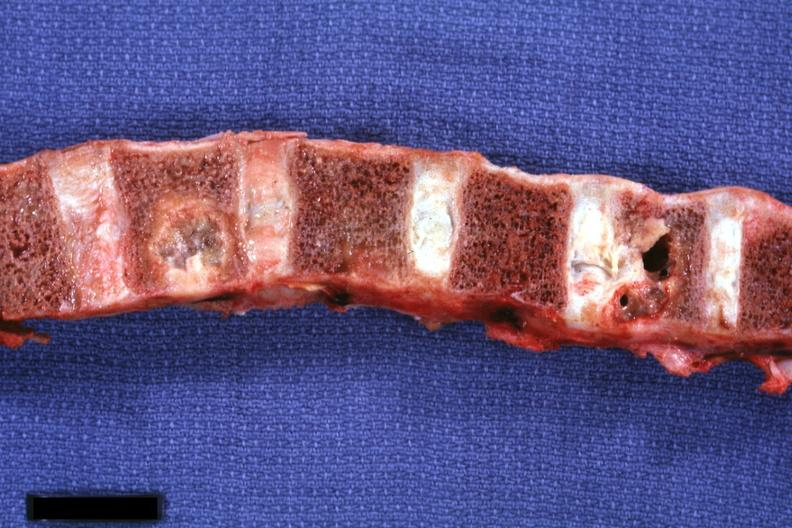s joints present?
Answer the question using a single word or phrase. Yes 